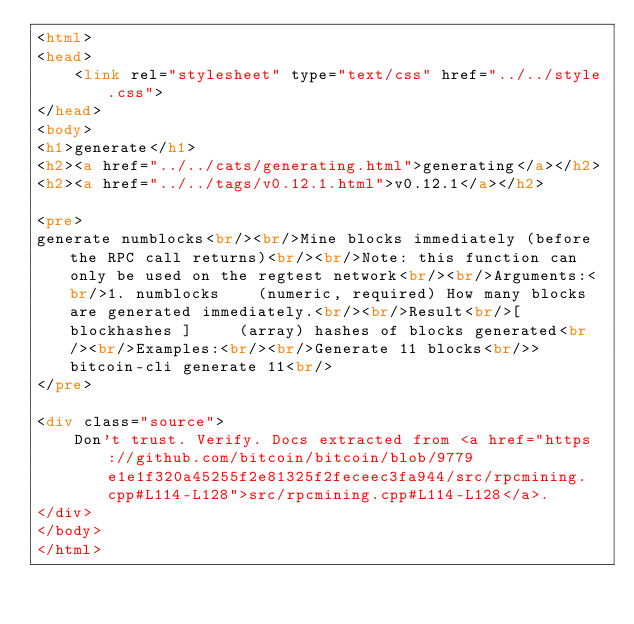<code> <loc_0><loc_0><loc_500><loc_500><_HTML_><html>
<head>
    <link rel="stylesheet" type="text/css" href="../../style.css">
</head>
<body>
<h1>generate</h1>
<h2><a href="../../cats/generating.html">generating</a></h2>
<h2><a href="../../tags/v0.12.1.html">v0.12.1</a></h2>

<pre>
generate numblocks<br/><br/>Mine blocks immediately (before the RPC call returns)<br/><br/>Note: this function can only be used on the regtest network<br/><br/>Arguments:<br/>1. numblocks    (numeric, required) How many blocks are generated immediately.<br/><br/>Result<br/>[ blockhashes ]     (array) hashes of blocks generated<br/><br/>Examples:<br/><br/>Generate 11 blocks<br/>> bitcoin-cli generate 11<br/>
</pre>

<div class="source">
    Don't trust. Verify. Docs extracted from <a href="https://github.com/bitcoin/bitcoin/blob/9779e1e1f320a45255f2e81325f2feceec3fa944/src/rpcmining.cpp#L114-L128">src/rpcmining.cpp#L114-L128</a>.
</div>
</body>
</html>
</code> 